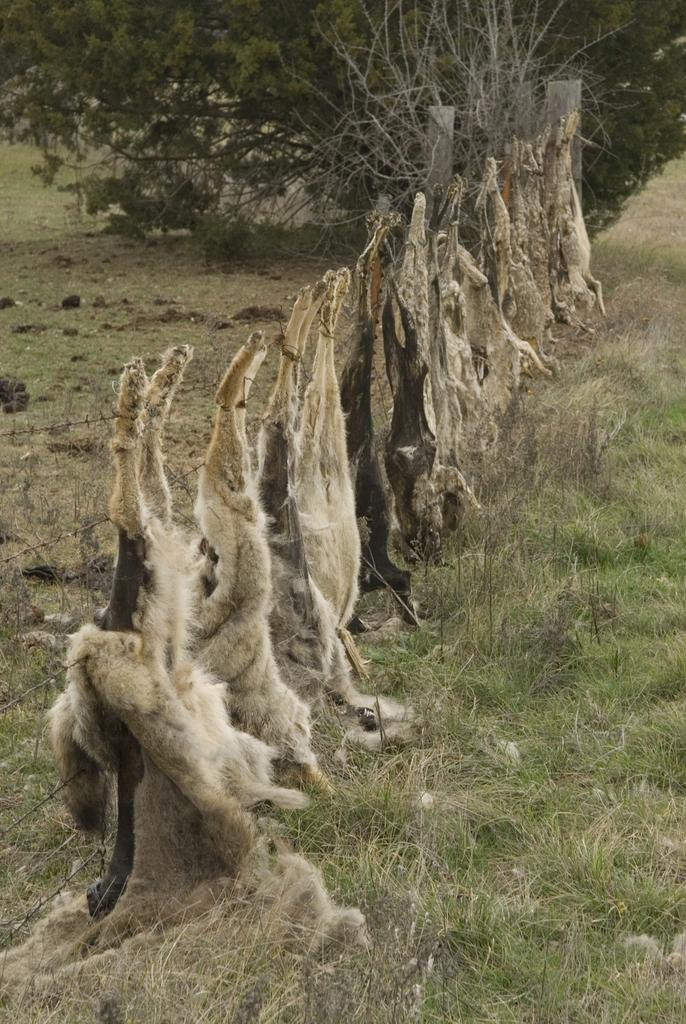What type of living organisms can be seen in the image? There are animals in the image. Where are the animals located in relation to the fence? The animals are behind a fence. What type of vegetation is visible at the bottom of the image? There is green grass visible at the bottom of the image. What can be seen at the top of the image? There is a tree at the top of the image. How many girls are playing with the toy in the image? There are no girls or toys present in the image; it features animals behind a fence. 